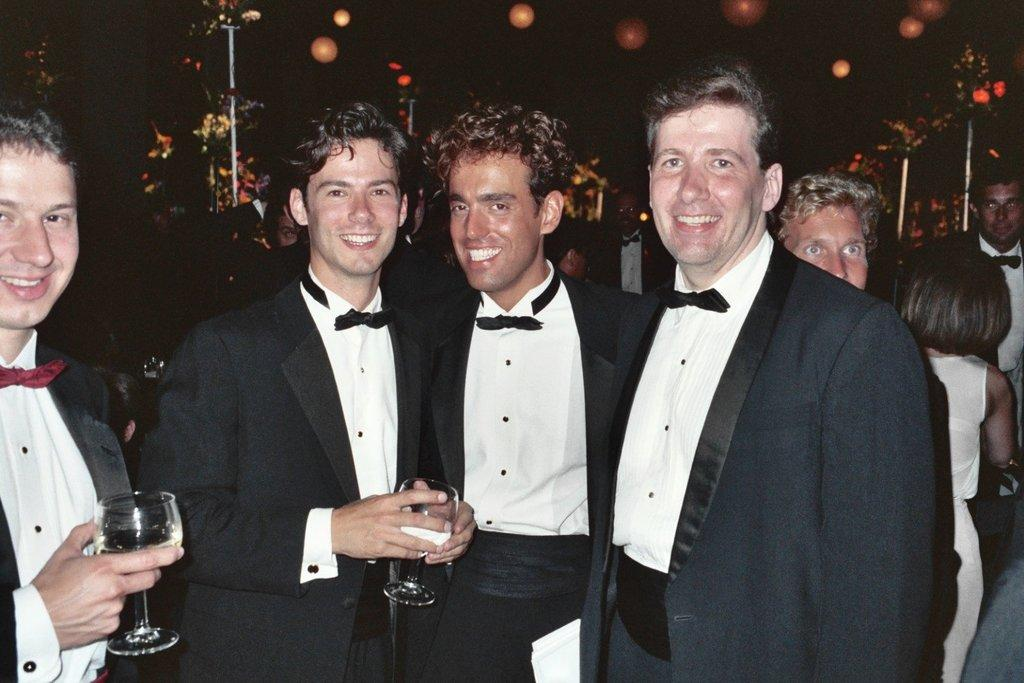How many people are in the image? There are four persons standing in the image. What is the facial expression of the people in the image? The four persons are smiling. Can you describe the scene behind the four persons? There are groups of people behind the four persons, and there are poles and lights visible in the background. What is the color of the background in the image? The background of the image is dark. What type of belief is being expressed by the zephyr in the image? There is no zephyr present in the image, and therefore no such expression of belief can be observed. 